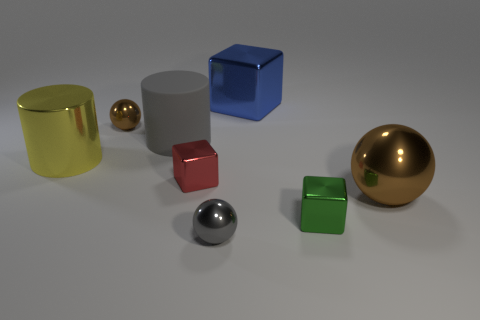Subtract all brown blocks. Subtract all green spheres. How many blocks are left? 3 Add 1 large purple blocks. How many objects exist? 9 Subtract all cylinders. How many objects are left? 6 Add 2 metallic cylinders. How many metallic cylinders are left? 3 Add 3 tiny balls. How many tiny balls exist? 5 Subtract 1 gray balls. How many objects are left? 7 Subtract all green metallic objects. Subtract all big cylinders. How many objects are left? 5 